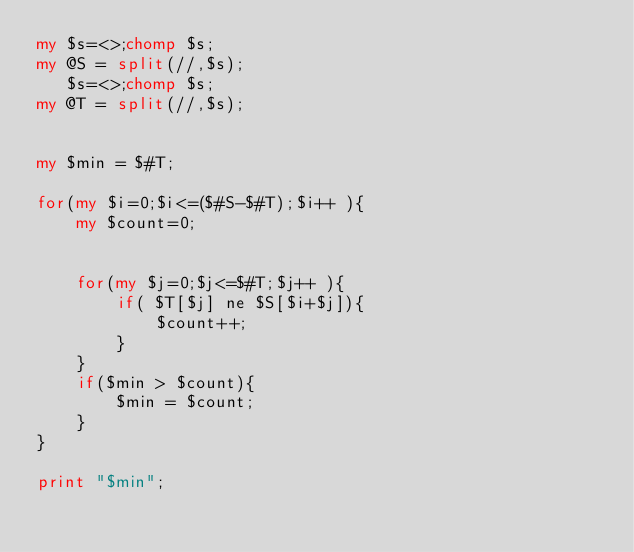Convert code to text. <code><loc_0><loc_0><loc_500><loc_500><_Perl_>my $s=<>;chomp $s;
my @S = split(//,$s);
   $s=<>;chomp $s;
my @T = split(//,$s);


my $min = $#T; 

for(my $i=0;$i<=($#S-$#T);$i++ ){
    my $count=0;
    
    
    for(my $j=0;$j<=$#T;$j++ ){
        if( $T[$j] ne $S[$i+$j]){
            $count++;
        }
    }
    if($min > $count){
        $min = $count;
    }
}

print "$min";</code> 